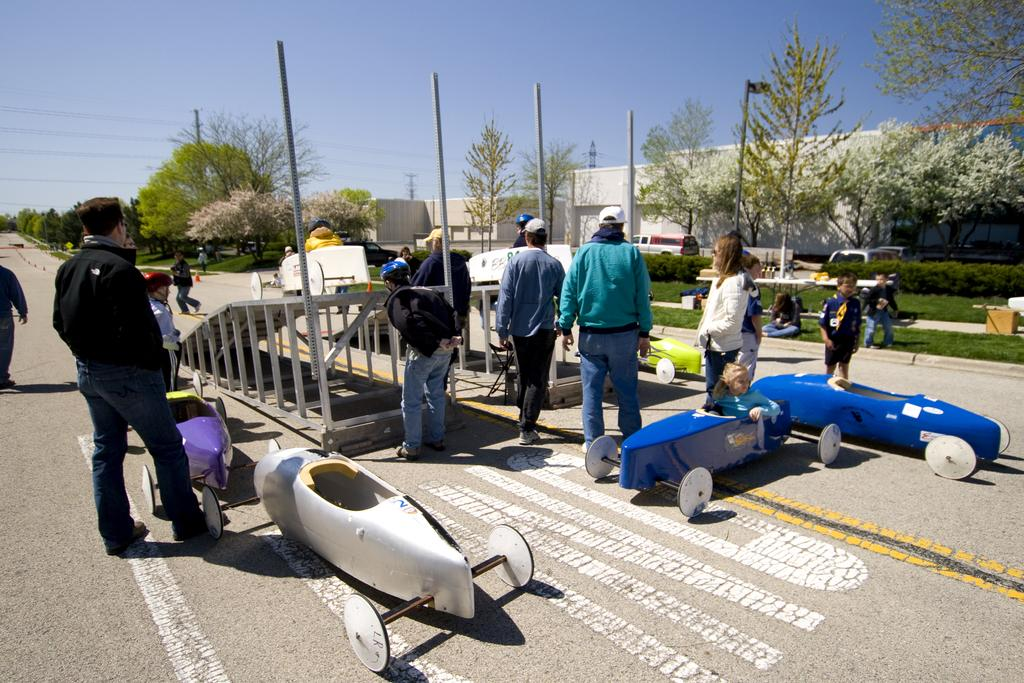What are the people in the image doing? The people are standing on the road and playing with kids. What can be seen in the background of the image? There are trees and buildings visible in the image. What type of animals can be seen at the zoo in the image? There is no zoo present in the image; it features people standing on the road and playing with kids. Can you tell me how many strangers are present in the image? The term "stranger" is subjective and cannot be definitively answered based on the provided facts. The image simply shows people standing on the road and playing with kids. 